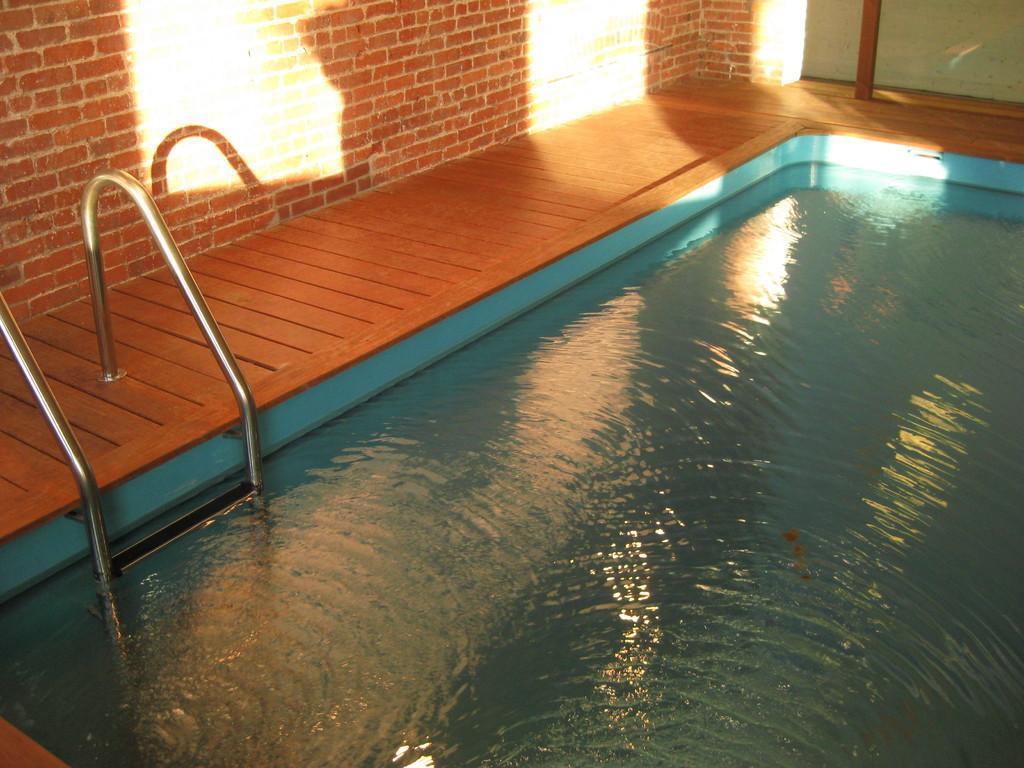How would you summarize this image in a sentence or two? In this image we can see a swimming pool. To the left side of the image there is wall. There is wooden flooring. 